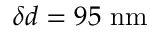Convert formula to latex. <formula><loc_0><loc_0><loc_500><loc_500>\delta d = 9 5 { n m }</formula> 